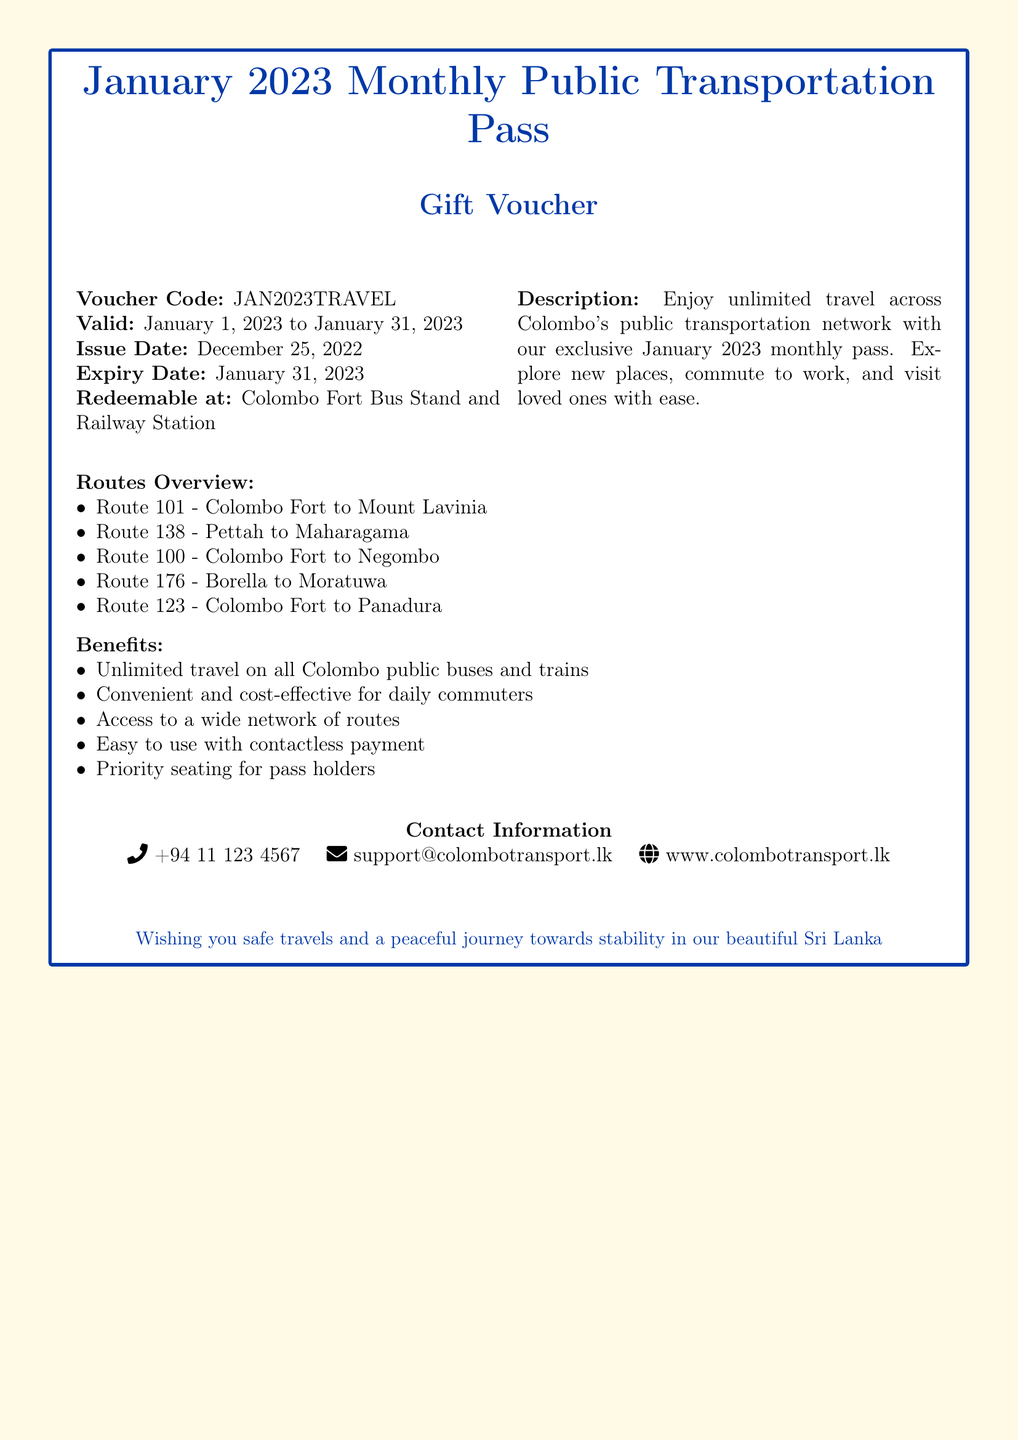What is the voucher code? The voucher code is important for redeeming the gift, and it is specifically mentioned in the document.
Answer: JAN2023TRAVEL What is the validity period of the voucher? The validity period indicates when the voucher can be used and is clearly stated in the document.
Answer: January 1, 2023 to January 31, 2023 When was the voucher issued? The issue date provides information on when the voucher became available for use.
Answer: December 25, 2022 Where can the voucher be redeemed? This information is crucial for users to know where they can utilize their voucher effectively.
Answer: Colombo Fort Bus Stand and Railway Station How many routes are listed in the Routes Overview? The number of routes available gives an overview of the transportation options provided by the voucher.
Answer: 5 What is one of the benefits of the monthly pass? Benefits highlight the advantages of using the voucher, providing insight into its utility.
Answer: Unlimited travel on all Colombo public buses and trains Is there priority seating for pass holders? This question involves understanding one of the stated benefits linked to the voucher.
Answer: Yes What kind of payment does the voucher support? Understanding the type of payment is important for users to plan their transport usage.
Answer: Contactless payment 